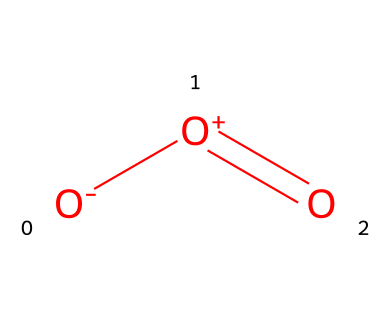How many oxygen atoms are present in this structure? The SMILES representation indicates there are three atoms of oxygen denoted by the "O" symbols.
Answer: three What type of bonding exists between these atoms? The representation shows a double bond between two oxygen atoms (with "=O") and single bonds with the negatively and positively charged oxygen atoms ([O-] and [O+]), indicating both ionic and covalent bonding.
Answer: ionic and covalent What is the charge on the terminal oxygen atom in this structure? The terminal oxygen atom is represented as [O-], indicating it carries a negative charge.
Answer: negative What is the molecular geometry of ozone? Ozone has a bent molecular geometry due to the arrangement of its three oxygen atoms and the lone pairs present, leading to a bond angle of approximately 117 degrees.
Answer: bent Which property of ozone is indicated by the presence of a double bond? The presence of a double bond suggests that ozone has a potential for high reactivity and is a strong oxidizing agent due to its ability to form multiple interactions.
Answer: high reactivity How does the presence of ozone affect air quality? Ozone acts as a pollutant at ground level, leading to decreased air quality as it can cause respiratory problems and damage to materials and vegetation.
Answer: decreases air quality 